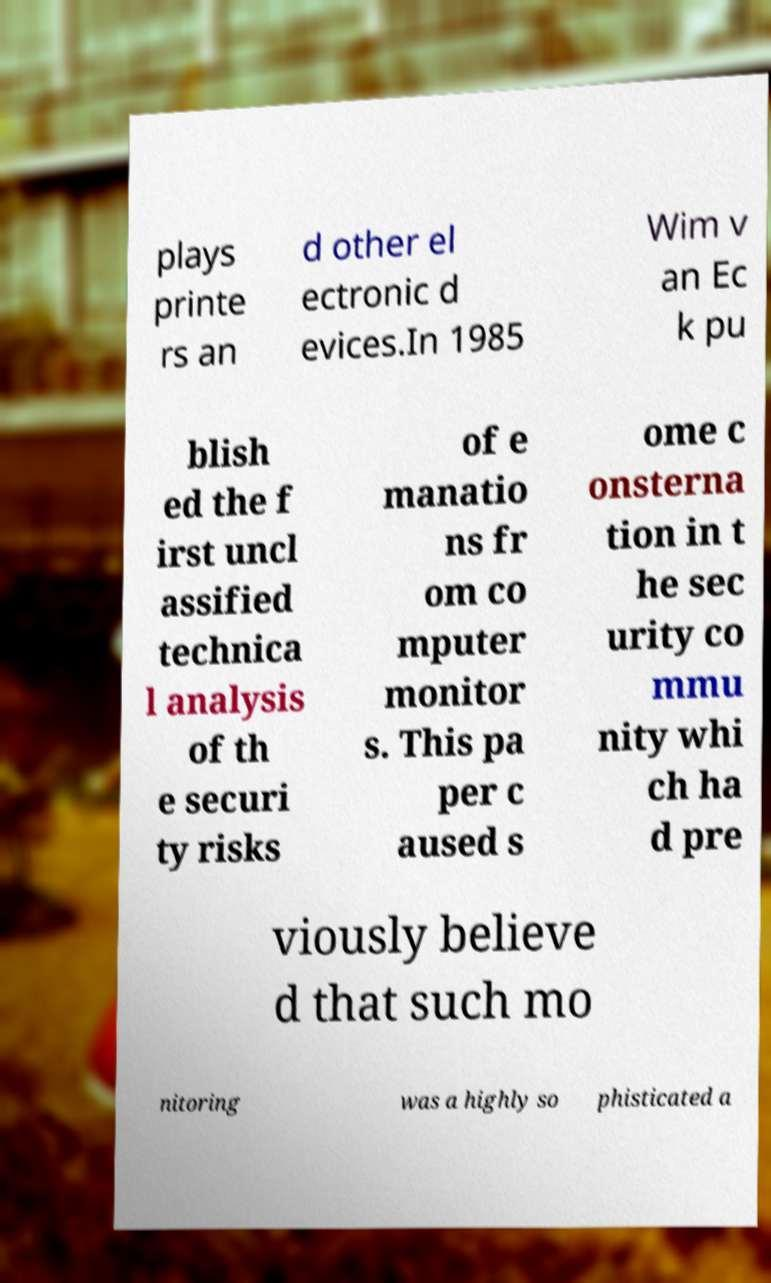Could you extract and type out the text from this image? plays printe rs an d other el ectronic d evices.In 1985 Wim v an Ec k pu blish ed the f irst uncl assified technica l analysis of th e securi ty risks of e manatio ns fr om co mputer monitor s. This pa per c aused s ome c onsterna tion in t he sec urity co mmu nity whi ch ha d pre viously believe d that such mo nitoring was a highly so phisticated a 